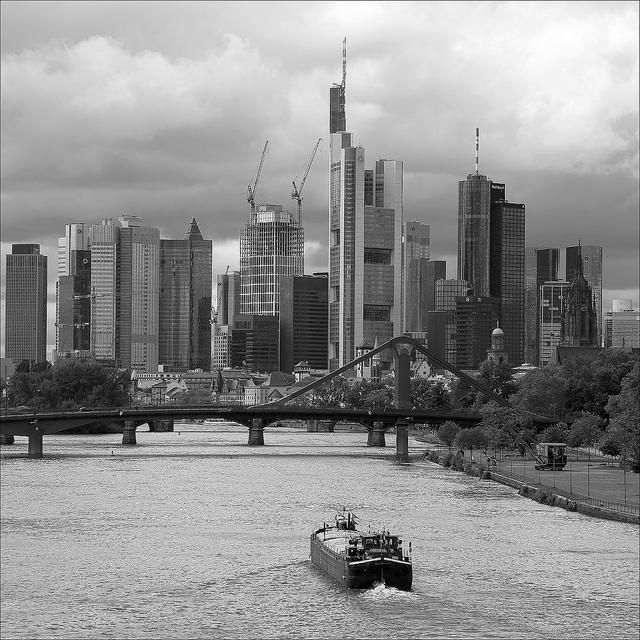What city skyline is this?
Keep it brief. New york. What kind of vehicle is in the photo?
Write a very short answer. Boat. Is this out in the country?
Write a very short answer. No. How many cranes are extending into the sky in the background?
Be succinct. 2. 